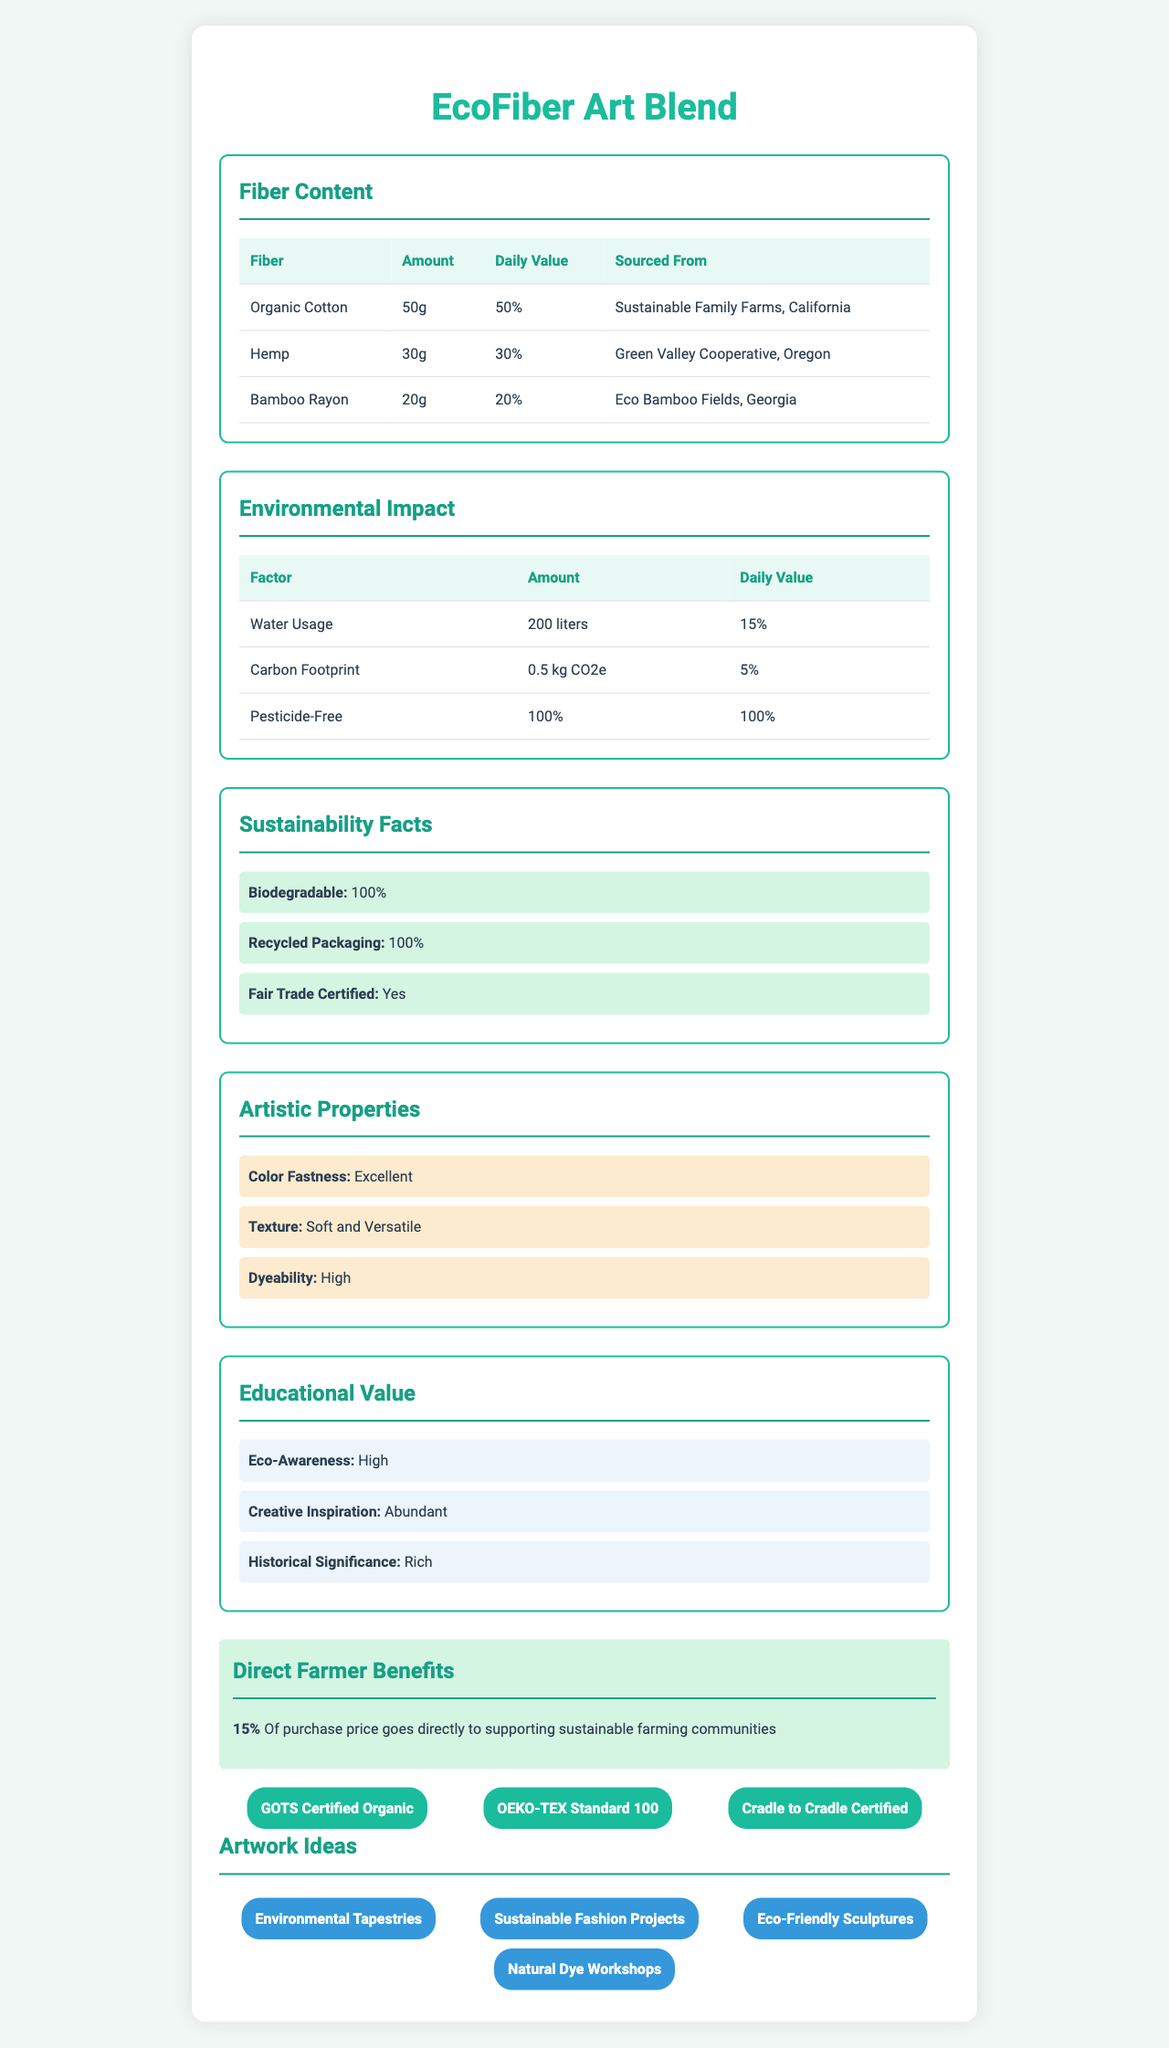what is the serving size of the EcoFiber Art Blend? The document specifies that one serving size is equivalent to one skein, which weighs 100g.
Answer: 1 skein (100g) what percentage of the EcoFiber Art Blend is made from organic cotton? According to the fiber content section, organic cotton makes up 50g out of the 100g skein, which is 50% of the total.
Answer: 50% where is the hemp in the EcoFiber Art Blend sourced from? The hemp is sourced from Green Valley Cooperative located in Oregon, as indicated in the fiber content section.
Answer: Green Valley Cooperative, Oregon what is the daily value percentage of the carbon footprint for the EcoFiber Art Blend? The environmental impact section lists the carbon footprint as having a daily value of 5%.
Answer: 5% is the EcoFiber Art Blend biodegradable? The sustainability facts section clearly states that the EcoFiber Art Blend is 100% biodegradable.
Answer: Yes which feature mentioned under artistic properties indicates how well the material can hold its color? A. Texture B. Color Fastness C. Dyeability Color Fastness indicates how well the material can hold its color, as listed under artistic properties.
Answer: B what is the significance of having 100% pesticide-free fibers in the EcoFiber Art Blend? A. Improved Textural Quality B. Lower Environmental Impact C. Better Color Fastness D. Enhanced Durability Having 100% pesticide-free fibers significantly lowers the environmental impact.
Answer: B does the EcoFiber Art Blend contribute to supporting farming communities directly? According to the document, 15% of the purchase price goes directly to supporting sustainable farming communities.
Answer: Yes summarize the main idea of the EcoFiber Art Blend Nutrition Facts document. This summary captures the comprehensive details provided in the document, covering the essential aspects of the EcoFiber Art Blend and its benefits.
Answer: The EcoFiber Art Blend Nutrition Facts document provides detailed information about the product's fiber content, environmental impact, sustainability facts, artistic properties, educational value, support for farmers, certifications, and artwork ideas. It highlights that the product consists of a blend of organic cotton, hemp, and bamboo rayon, sourced from sustainable farms, and emphasizes its eco-friendly properties, including being biodegradable and pesticide-free. The document also promotes the product's artistic qualities and suggests various eco-themed artwork ideas that can be created using the blend. what certifications does the EcoFiber Art Blend have? The document lists these three certifications under the certifications section.
Answer: GOTS Certified Organic, OEKO-TEX Standard 100, Cradle to Cradle Certified how much water is used in the production of one skein of EcoFiber Art Blend? The environmental impact section indicates that the water usage for one skein is 200 liters.
Answer: 200 liters which artistic property is not mentioned in the document? A. Weight B. Color Fastness C. Dyeability D. Texture The document does not mention weight as an artistic property.
Answer: A how much of the EcoFiber Art Blend is sourced from Eco Bamboo Fields in Georgia? As per the fiber content section, 20g of bamboo rayon is sourced from Eco Bamboo Fields in Georgia.
Answer: 20g what is the primary benefit listed under educational value? The primary benefit listed under educational value is Eco-Awareness.
Answer: Eco-Awareness does the document specify the exact carbon footprint in kg CO2e for the EcoFiber Art Blend? The document specifies that the carbon footprint is 0.5 kg CO2e.
Answer: Yes what specific printing method is used for the packaging of the EcoFiber Art Blend? The document does not provide any details on the printing method used for the packaging.
Answer: Cannot be determined 